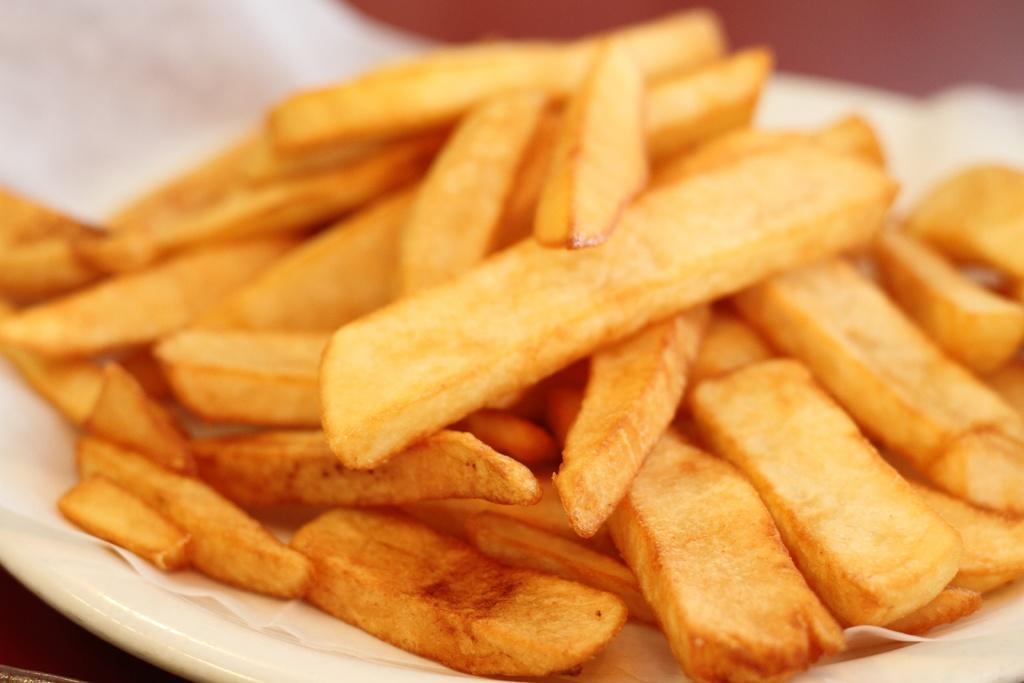In one or two sentences, can you explain what this image depicts? This image contains a plate having a paper which is having few fries on it. 